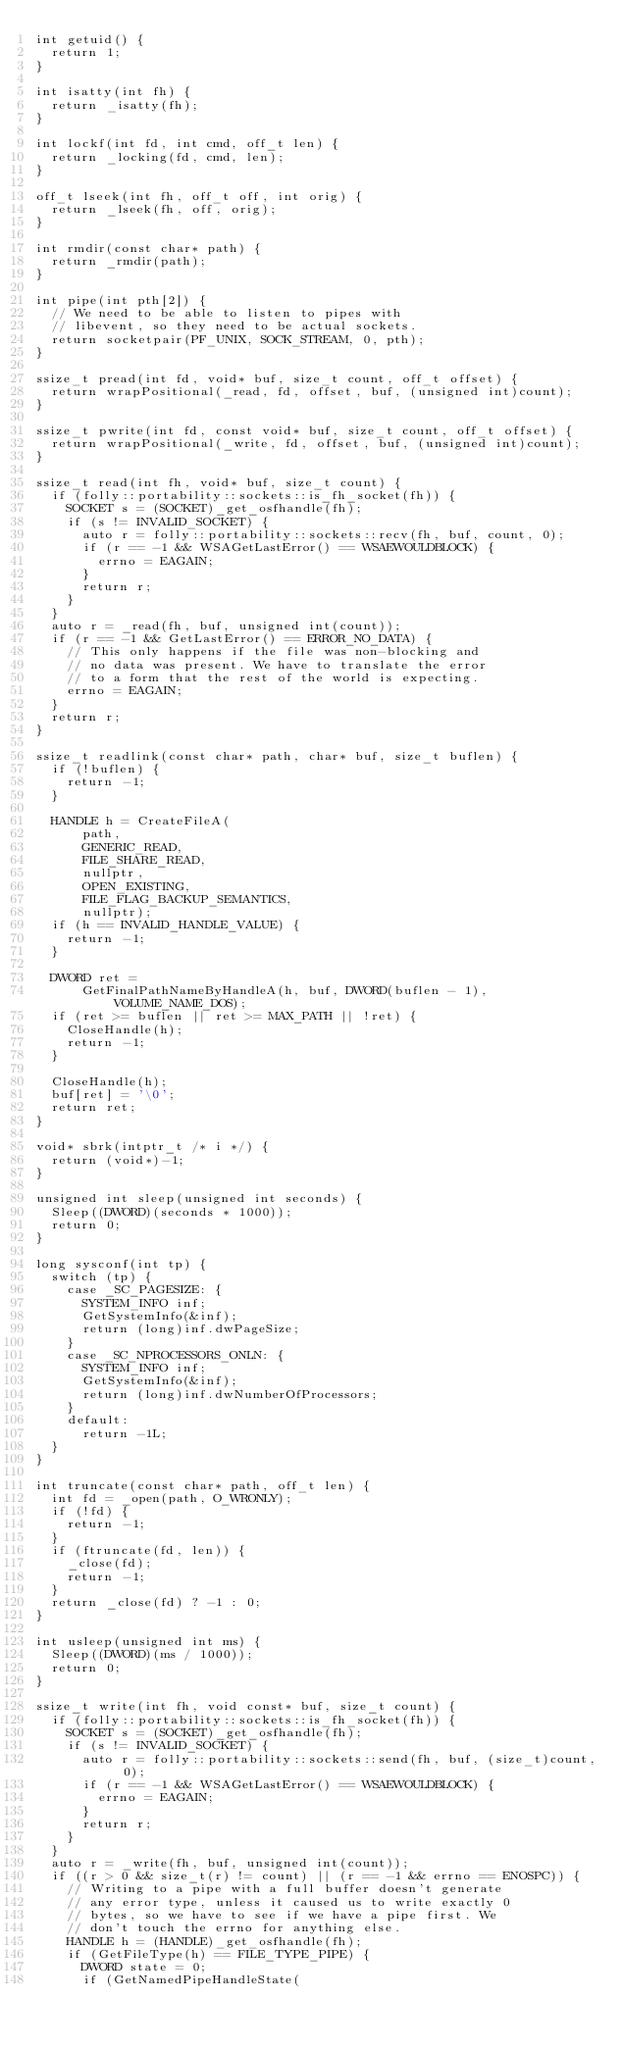Convert code to text. <code><loc_0><loc_0><loc_500><loc_500><_C++_>int getuid() {
  return 1;
}

int isatty(int fh) {
  return _isatty(fh);
}

int lockf(int fd, int cmd, off_t len) {
  return _locking(fd, cmd, len);
}

off_t lseek(int fh, off_t off, int orig) {
  return _lseek(fh, off, orig);
}

int rmdir(const char* path) {
  return _rmdir(path);
}

int pipe(int pth[2]) {
  // We need to be able to listen to pipes with
  // libevent, so they need to be actual sockets.
  return socketpair(PF_UNIX, SOCK_STREAM, 0, pth);
}

ssize_t pread(int fd, void* buf, size_t count, off_t offset) {
  return wrapPositional(_read, fd, offset, buf, (unsigned int)count);
}

ssize_t pwrite(int fd, const void* buf, size_t count, off_t offset) {
  return wrapPositional(_write, fd, offset, buf, (unsigned int)count);
}

ssize_t read(int fh, void* buf, size_t count) {
  if (folly::portability::sockets::is_fh_socket(fh)) {
    SOCKET s = (SOCKET)_get_osfhandle(fh);
    if (s != INVALID_SOCKET) {
      auto r = folly::portability::sockets::recv(fh, buf, count, 0);
      if (r == -1 && WSAGetLastError() == WSAEWOULDBLOCK) {
        errno = EAGAIN;
      }
      return r;
    }
  }
  auto r = _read(fh, buf, unsigned int(count));
  if (r == -1 && GetLastError() == ERROR_NO_DATA) {
    // This only happens if the file was non-blocking and
    // no data was present. We have to translate the error
    // to a form that the rest of the world is expecting.
    errno = EAGAIN;
  }
  return r;
}

ssize_t readlink(const char* path, char* buf, size_t buflen) {
  if (!buflen) {
    return -1;
  }

  HANDLE h = CreateFileA(
      path,
      GENERIC_READ,
      FILE_SHARE_READ,
      nullptr,
      OPEN_EXISTING,
      FILE_FLAG_BACKUP_SEMANTICS,
      nullptr);
  if (h == INVALID_HANDLE_VALUE) {
    return -1;
  }

  DWORD ret =
      GetFinalPathNameByHandleA(h, buf, DWORD(buflen - 1), VOLUME_NAME_DOS);
  if (ret >= buflen || ret >= MAX_PATH || !ret) {
    CloseHandle(h);
    return -1;
  }

  CloseHandle(h);
  buf[ret] = '\0';
  return ret;
}

void* sbrk(intptr_t /* i */) {
  return (void*)-1;
}

unsigned int sleep(unsigned int seconds) {
  Sleep((DWORD)(seconds * 1000));
  return 0;
}

long sysconf(int tp) {
  switch (tp) {
    case _SC_PAGESIZE: {
      SYSTEM_INFO inf;
      GetSystemInfo(&inf);
      return (long)inf.dwPageSize;
    }
    case _SC_NPROCESSORS_ONLN: {
      SYSTEM_INFO inf;
      GetSystemInfo(&inf);
      return (long)inf.dwNumberOfProcessors;
    }
    default:
      return -1L;
  }
}

int truncate(const char* path, off_t len) {
  int fd = _open(path, O_WRONLY);
  if (!fd) {
    return -1;
  }
  if (ftruncate(fd, len)) {
    _close(fd);
    return -1;
  }
  return _close(fd) ? -1 : 0;
}

int usleep(unsigned int ms) {
  Sleep((DWORD)(ms / 1000));
  return 0;
}

ssize_t write(int fh, void const* buf, size_t count) {
  if (folly::portability::sockets::is_fh_socket(fh)) {
    SOCKET s = (SOCKET)_get_osfhandle(fh);
    if (s != INVALID_SOCKET) {
      auto r = folly::portability::sockets::send(fh, buf, (size_t)count, 0);
      if (r == -1 && WSAGetLastError() == WSAEWOULDBLOCK) {
        errno = EAGAIN;
      }
      return r;
    }
  }
  auto r = _write(fh, buf, unsigned int(count));
  if ((r > 0 && size_t(r) != count) || (r == -1 && errno == ENOSPC)) {
    // Writing to a pipe with a full buffer doesn't generate
    // any error type, unless it caused us to write exactly 0
    // bytes, so we have to see if we have a pipe first. We
    // don't touch the errno for anything else.
    HANDLE h = (HANDLE)_get_osfhandle(fh);
    if (GetFileType(h) == FILE_TYPE_PIPE) {
      DWORD state = 0;
      if (GetNamedPipeHandleState(</code> 